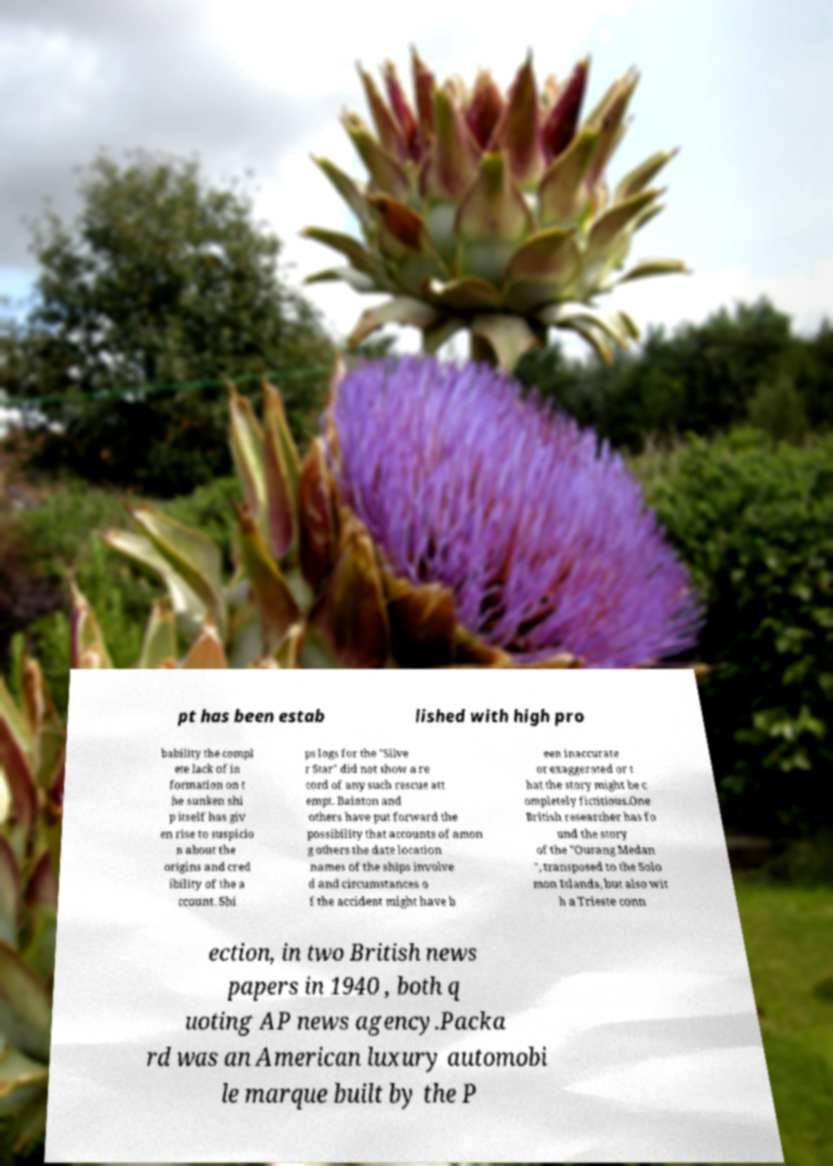Please read and relay the text visible in this image. What does it say? pt has been estab lished with high pro bability the compl ete lack of in formation on t he sunken shi p itself has giv en rise to suspicio n about the origins and cred ibility of the a ccount. Shi ps logs for the "Silve r Star" did not show a re cord of any such rescue att empt. Bainton and others have put forward the possibility that accounts of amon g others the date location names of the ships involve d and circumstances o f the accident might have b een inaccurate or exaggerated or t hat the story might be c ompletely fictitious.One British researcher has fo und the story of the "Ourang Medan ", transposed to the Solo mon Islands, but also wit h a Trieste conn ection, in two British news papers in 1940 , both q uoting AP news agency.Packa rd was an American luxury automobi le marque built by the P 